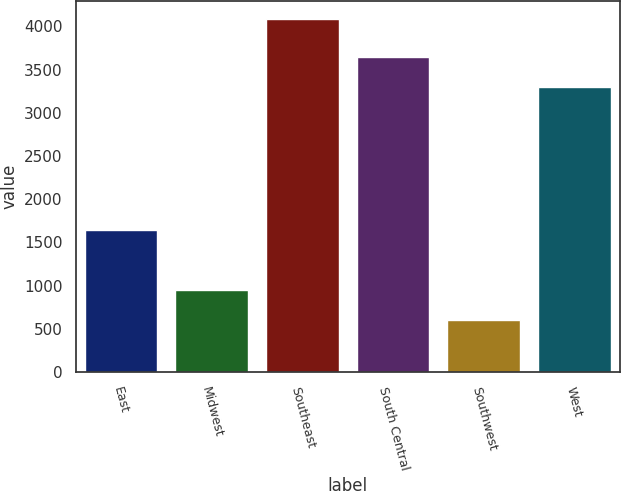Convert chart to OTSL. <chart><loc_0><loc_0><loc_500><loc_500><bar_chart><fcel>East<fcel>Midwest<fcel>Southeast<fcel>South Central<fcel>Southwest<fcel>West<nl><fcel>1640.1<fcel>946.51<fcel>4087.6<fcel>3645.71<fcel>597.5<fcel>3296.7<nl></chart> 